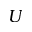<formula> <loc_0><loc_0><loc_500><loc_500>U</formula> 